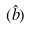<formula> <loc_0><loc_0><loc_500><loc_500>( \hat { b } )</formula> 